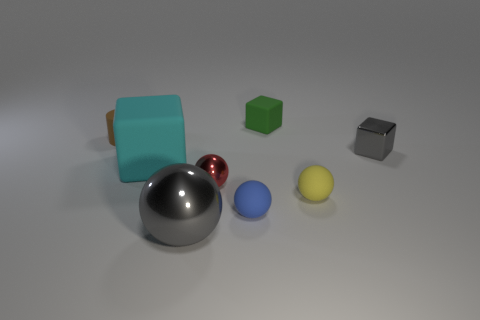How many metal objects are either gray objects or small balls?
Your response must be concise. 3. There is a tiny thing to the right of the small sphere that is on the right side of the small block behind the tiny brown rubber object; what is its material?
Provide a short and direct response. Metal. There is a gray object that is behind the rubber cube in front of the gray block; what is its material?
Your answer should be very brief. Metal. Do the gray metallic thing that is right of the big gray sphere and the rubber block behind the tiny gray shiny object have the same size?
Make the answer very short. Yes. What number of large things are brown cylinders or spheres?
Keep it short and to the point. 1. What number of things are either gray metal things on the right side of the small red object or blue rubber objects?
Offer a terse response. 2. Is the color of the big ball the same as the tiny metal block?
Your response must be concise. Yes. What number of other things are the same shape as the red thing?
Keep it short and to the point. 3. How many blue things are tiny matte cubes or big balls?
Provide a succinct answer. 0. What is the color of the cylinder that is the same material as the green object?
Ensure brevity in your answer.  Brown. 